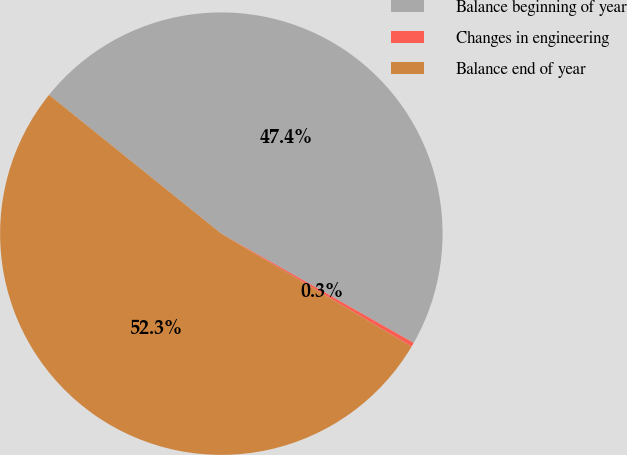Convert chart. <chart><loc_0><loc_0><loc_500><loc_500><pie_chart><fcel>Balance beginning of year<fcel>Changes in engineering<fcel>Balance end of year<nl><fcel>47.43%<fcel>0.31%<fcel>52.26%<nl></chart> 